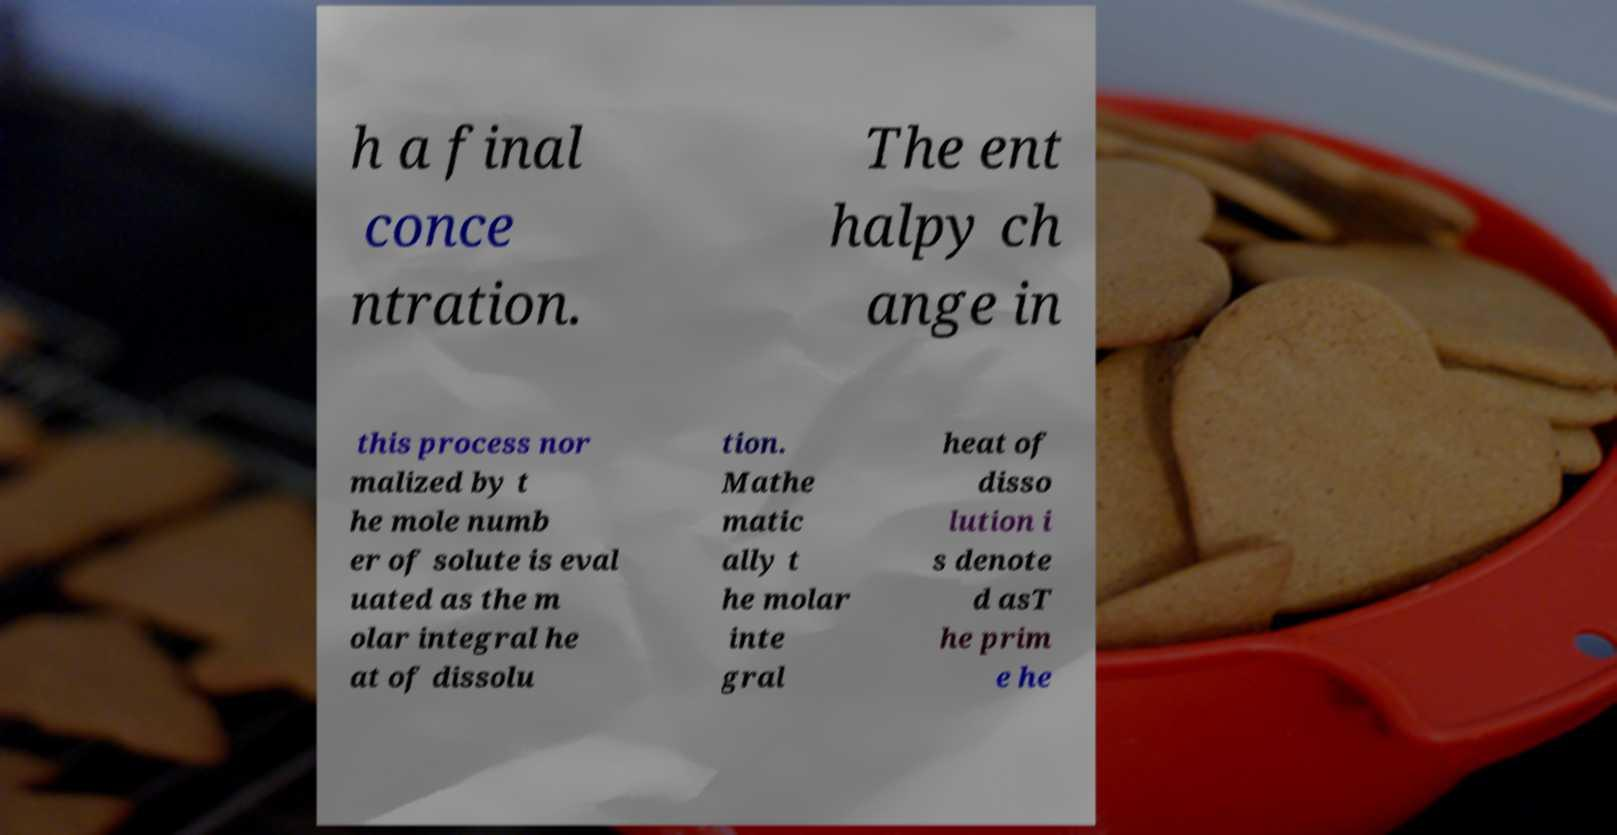What messages or text are displayed in this image? I need them in a readable, typed format. h a final conce ntration. The ent halpy ch ange in this process nor malized by t he mole numb er of solute is eval uated as the m olar integral he at of dissolu tion. Mathe matic ally t he molar inte gral heat of disso lution i s denote d asT he prim e he 